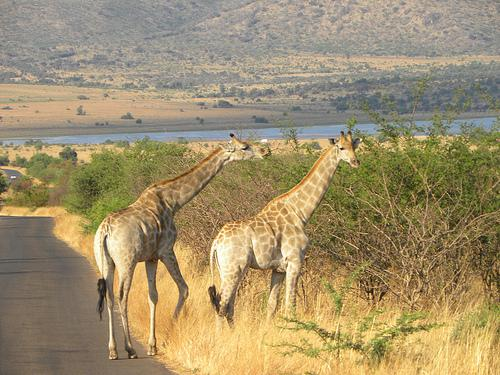Question: what kind of animals are shown?
Choices:
A. Zebras.
B. Lions.
C. Giraffes.
D. Frogs.
Answer with the letter. Answer: C Question: how many giraffes are shown?
Choices:
A. Three.
B. Four.
C. Two.
D. Five.
Answer with the letter. Answer: C Question: what is in the background?
Choices:
A. Water.
B. Trees.
C. Barn.
D. Hill.
Answer with the letter. Answer: D 